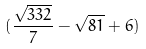<formula> <loc_0><loc_0><loc_500><loc_500>( \frac { \sqrt { 3 3 2 } } { 7 } - \sqrt { 8 1 } + 6 )</formula> 